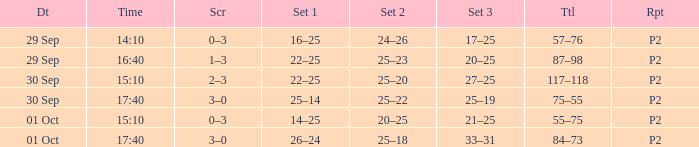For a date of 29 Sep and a time of 16:40, what is the corresponding Set 3? 20–25. 